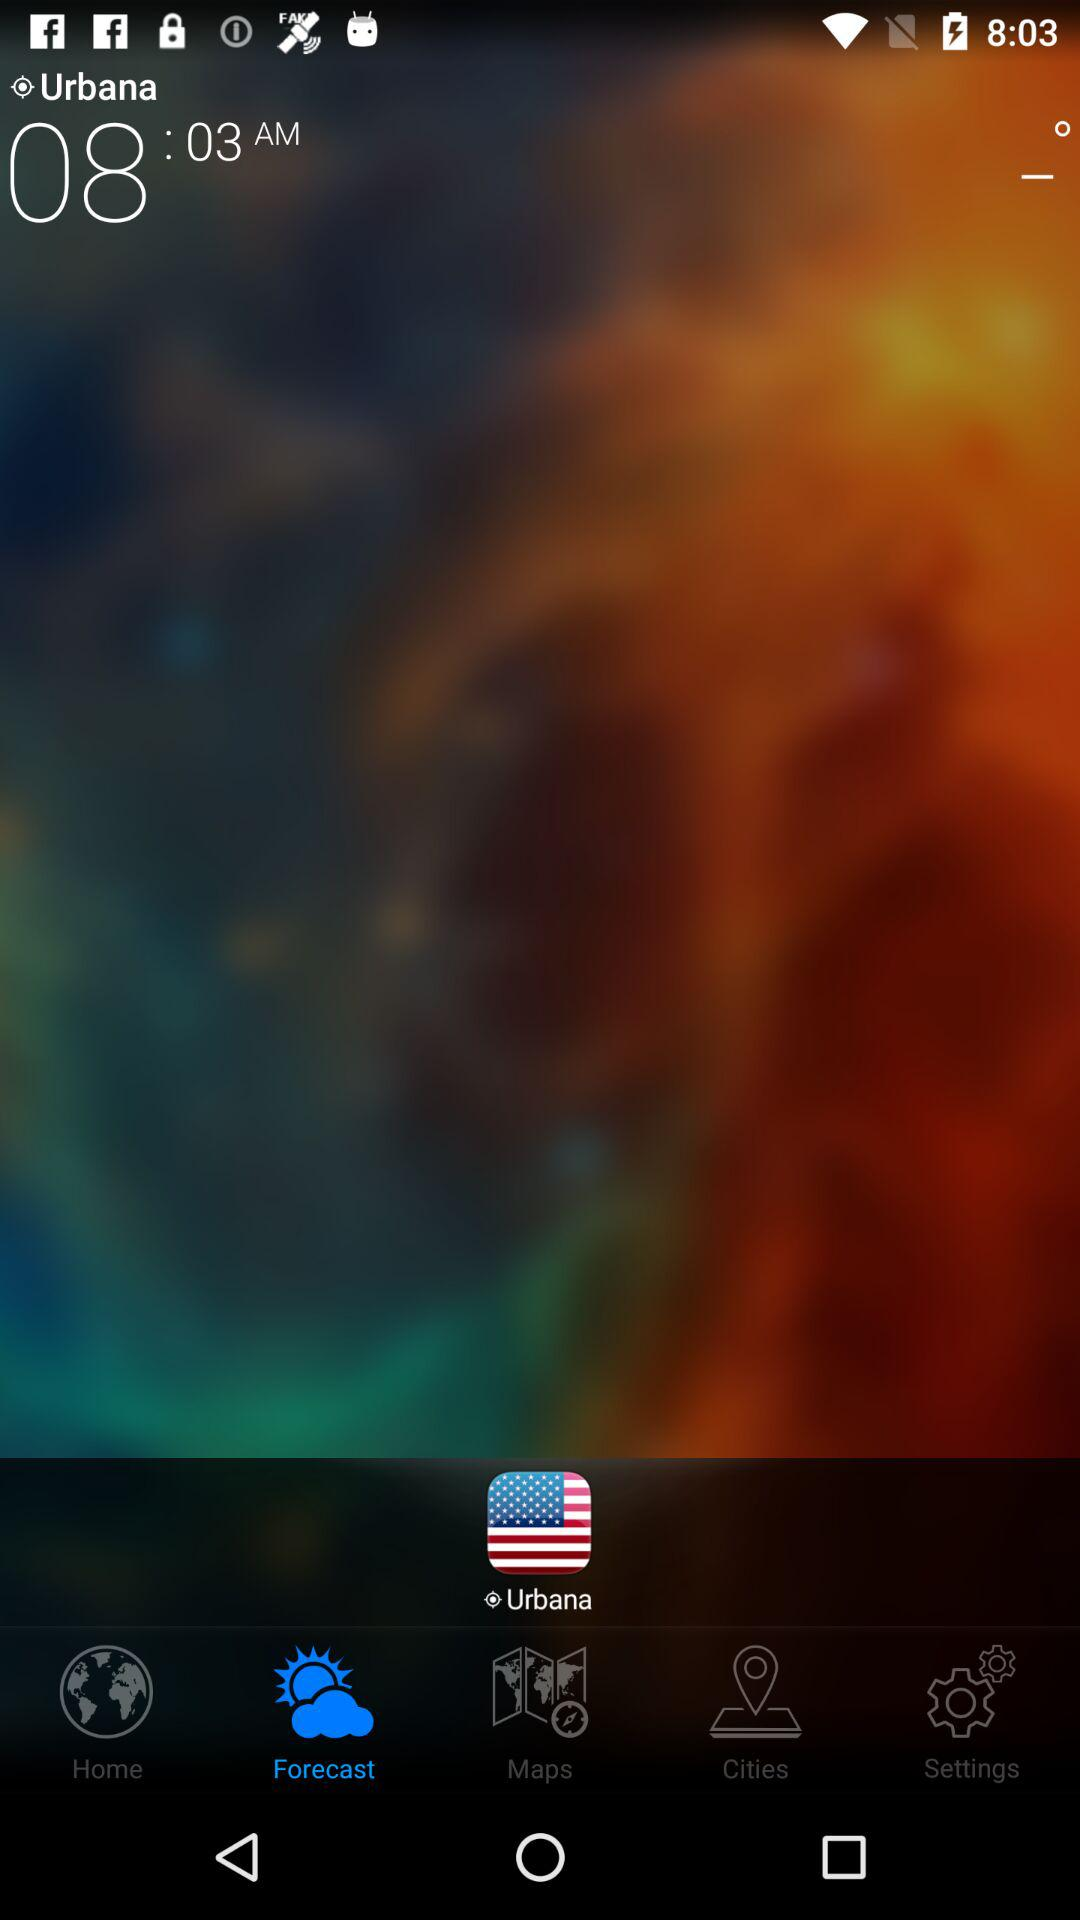What time is shown on the screen? The shown time is 8:03 a.m. 